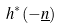Convert formula to latex. <formula><loc_0><loc_0><loc_500><loc_500>h ^ { * } ( - \underline { n } )</formula> 